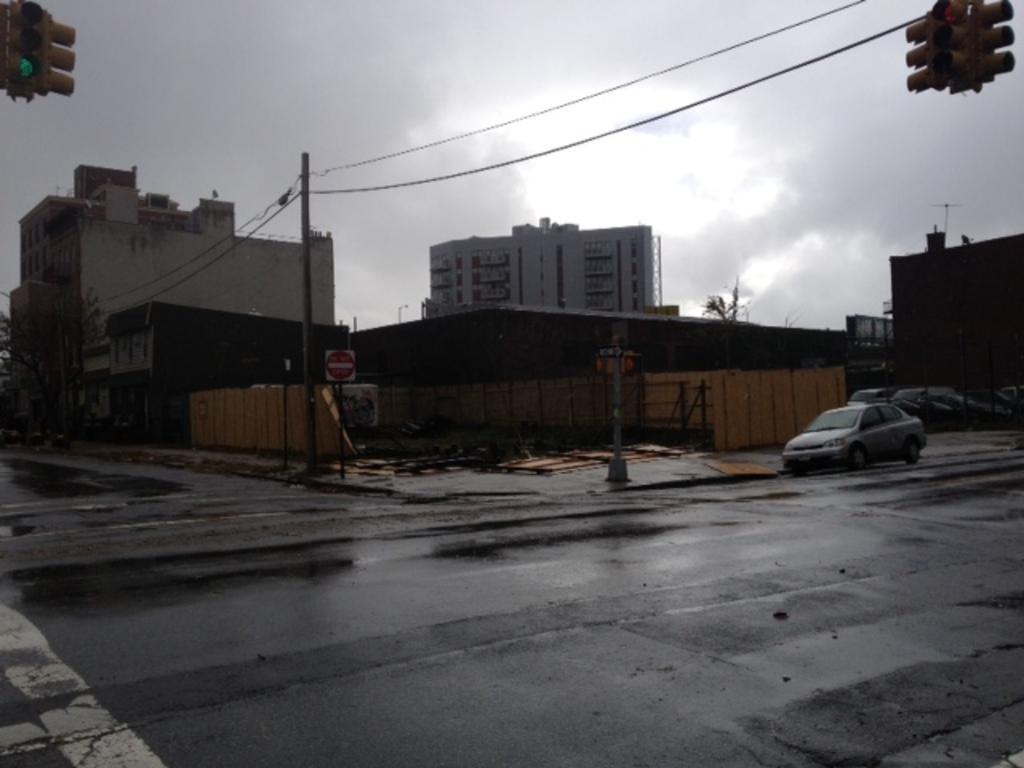How would you summarize this image in a sentence or two? In this image we can see a car on the wet road. On the backside we can see some buildings, pole with wires, traffic lights, board and the sky which looks cloudy. 